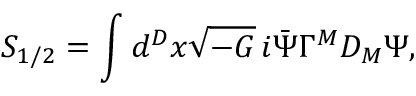Convert formula to latex. <formula><loc_0><loc_0><loc_500><loc_500>S _ { 1 / 2 } = \int d ^ { D } x \sqrt { - G } \, i \bar { \Psi } \Gamma ^ { M } D _ { M } \Psi ,</formula> 